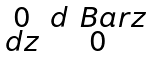<formula> <loc_0><loc_0><loc_500><loc_500>\begin{smallmatrix} 0 & d \ B a r { z } \\ d z & 0 \end{smallmatrix}</formula> 